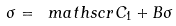<formula> <loc_0><loc_0><loc_500><loc_500>\sigma = \ m a t h s c r { C } _ { 1 } + B \sigma</formula> 